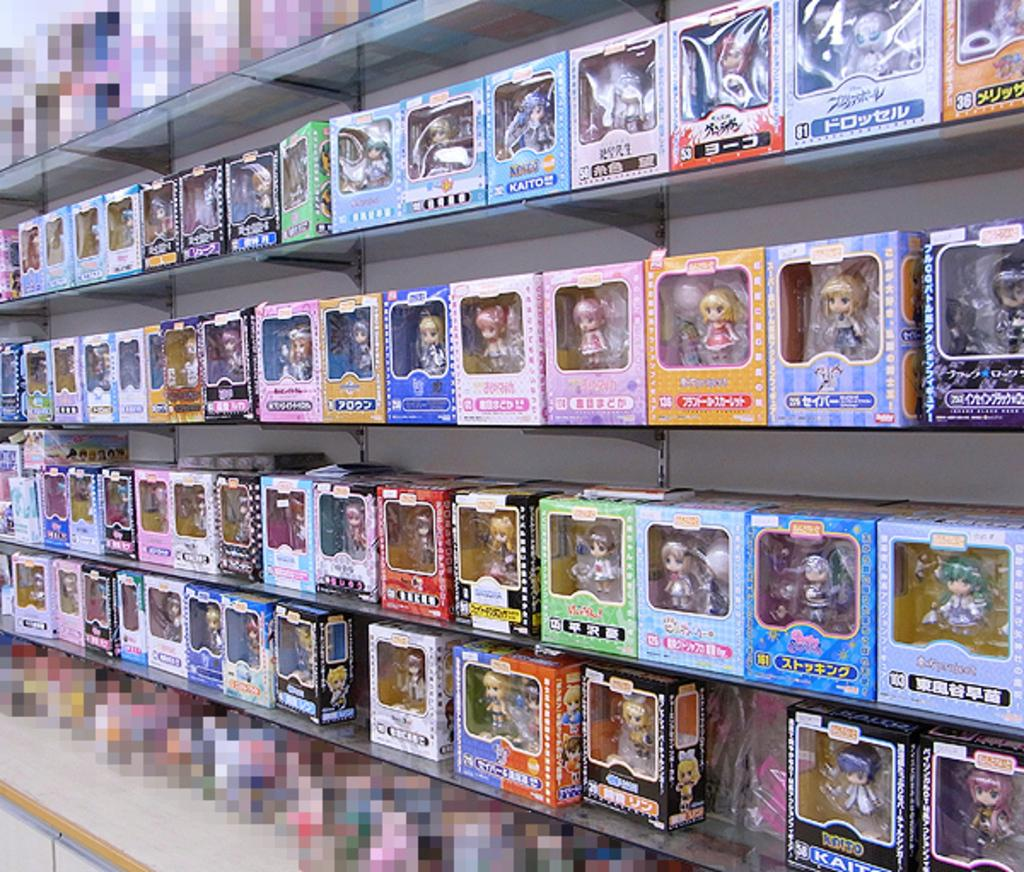What objects are in the image? There are toys in the image. Where are the toys located in the image? The toys are in the center of the image. How are the toys arranged in the image? The toys are kept on shelves. What type of wound can be seen on the toys in the image? There are no wounds visible on the toys in the image. What kind of wax is used to create the toys in the image? The toys in the image are not made of wax, so it is not possible to determine what type of wax might have been used. 